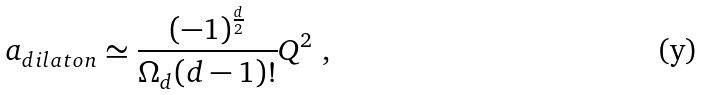<formula> <loc_0><loc_0><loc_500><loc_500>a _ { d i l a t o n } \simeq \frac { ( - 1 ) ^ { \frac { d } { 2 } } } { \Omega _ { d } ( d - 1 ) ! } Q ^ { 2 } \ ,</formula> 